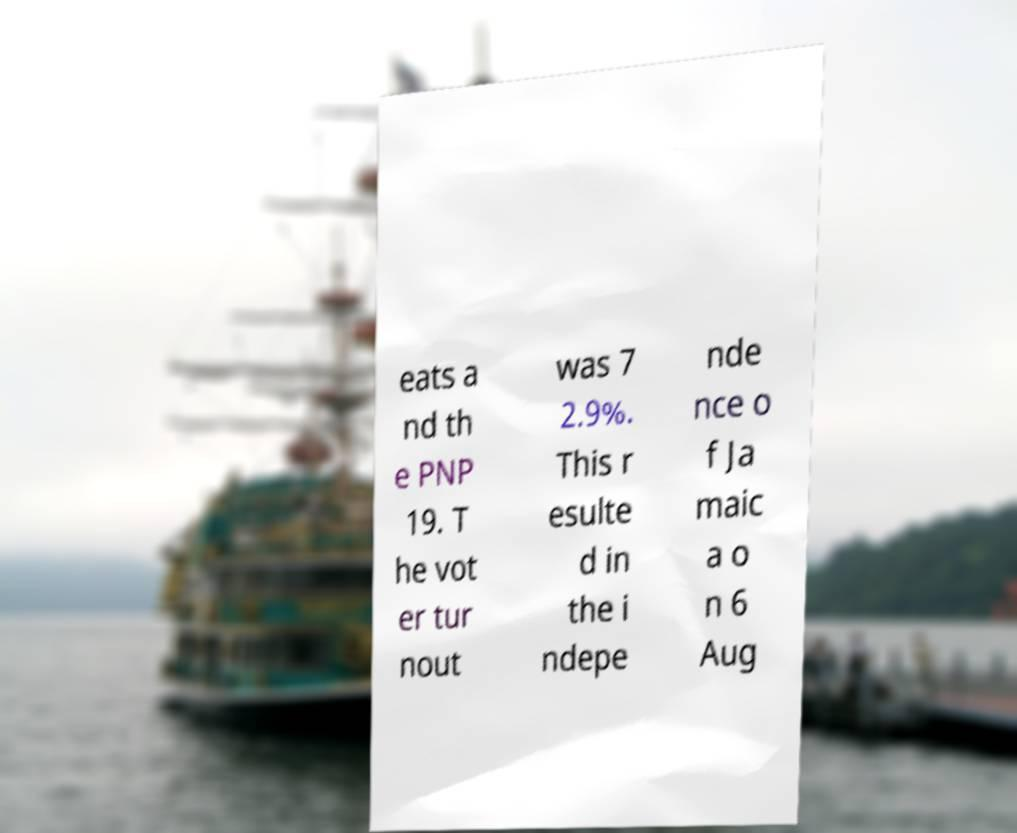I need the written content from this picture converted into text. Can you do that? eats a nd th e PNP 19. T he vot er tur nout was 7 2.9%. This r esulte d in the i ndepe nde nce o f Ja maic a o n 6 Aug 